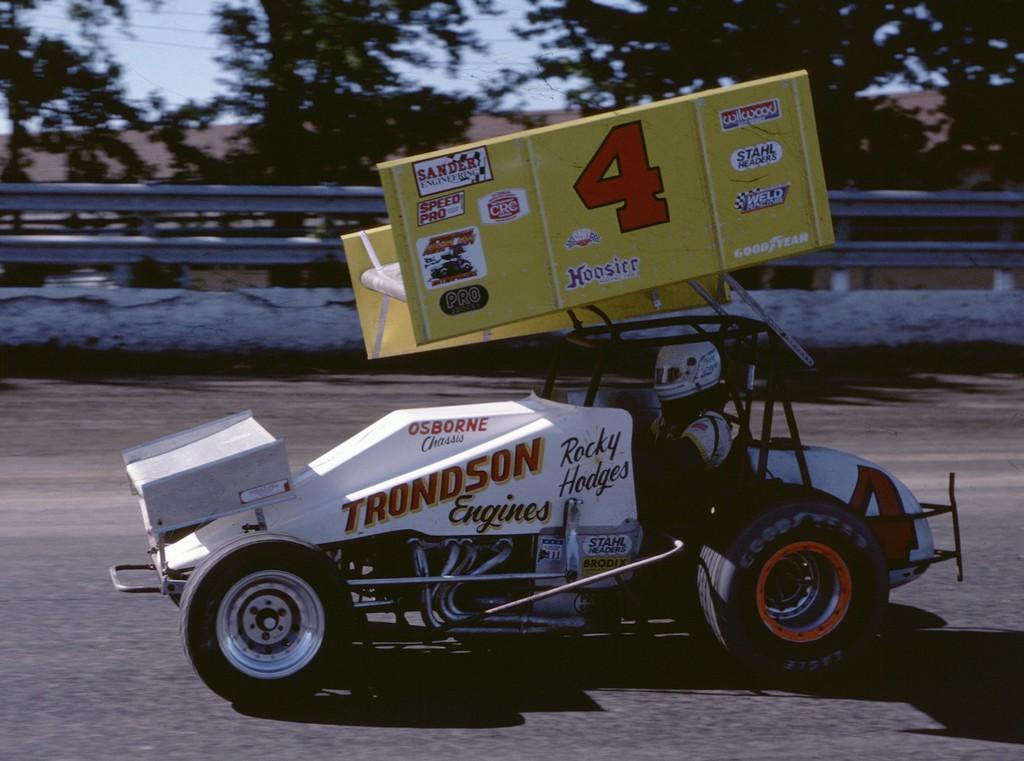Can you describe this image briefly? In this image there is a person riding a racing car with sponsor boards on top of it, beside the car there is a metal rod fence on the concrete wall, behind that there are trees, cables and a building. 